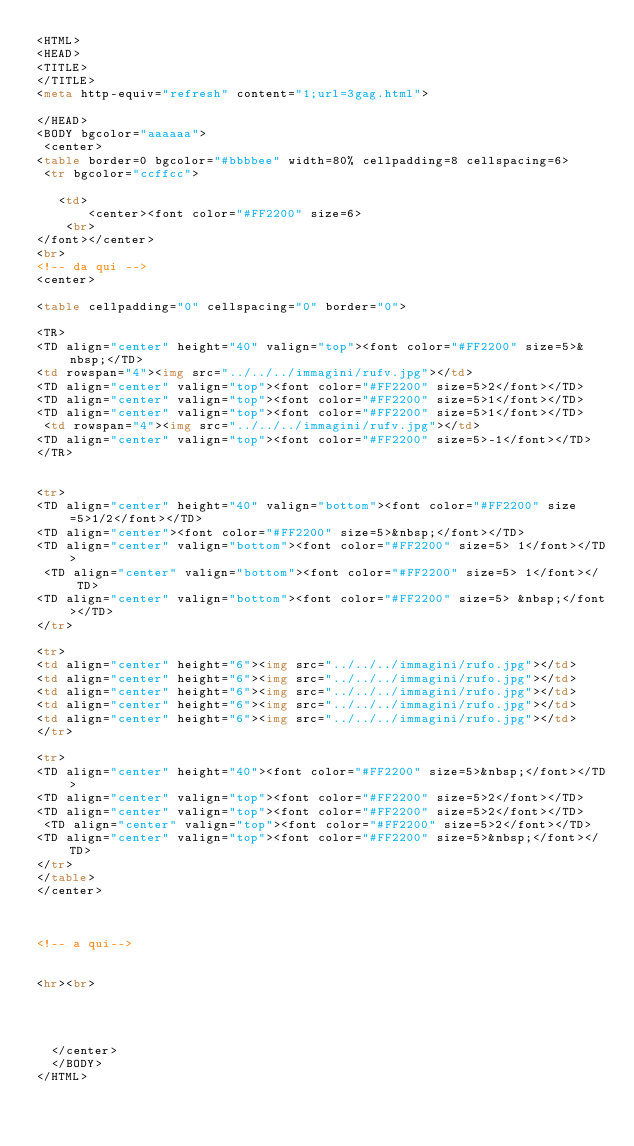Convert code to text. <code><loc_0><loc_0><loc_500><loc_500><_HTML_><HTML>
<HEAD>
<TITLE>  
</TITLE>
<meta http-equiv="refresh" content="1;url=3gag.html">

</HEAD>
<BODY bgcolor="aaaaaa">
 <center>
<table border=0 bgcolor="#bbbbee" width=80% cellpadding=8 cellspacing=6>
 <tr bgcolor="ccffcc">

   <td>
       <center><font color="#FF2200" size=6>
    <br>   
</font></center>
<br>
<!-- da qui -->
<center>

<table cellpadding="0" cellspacing="0" border="0">

<TR>
<TD align="center" height="40" valign="top"><font color="#FF2200" size=5>&nbsp;</TD>
<td rowspan="4"><img src="../../../immagini/rufv.jpg"></td>
<TD align="center" valign="top"><font color="#FF2200" size=5>2</font></TD>
<TD align="center" valign="top"><font color="#FF2200" size=5>1</font></TD>
<TD align="center" valign="top"><font color="#FF2200" size=5>1</font></TD>
 <td rowspan="4"><img src="../../../immagini/rufv.jpg"></td>
<TD align="center" valign="top"><font color="#FF2200" size=5>-1</font></TD>
</TR>

 
<tr>
<TD align="center" height="40" valign="bottom"><font color="#FF2200" size=5>1/2</font></TD>
<TD align="center"><font color="#FF2200" size=5>&nbsp;</font></TD>
<TD align="center" valign="bottom"><font color="#FF2200" size=5> 1</font></TD>
 <TD align="center" valign="bottom"><font color="#FF2200" size=5> 1</font></TD>
<TD align="center" valign="bottom"><font color="#FF2200" size=5> &nbsp;</font></TD>
</tr>

<tr>
<td align="center" height="6"><img src="../../../immagini/rufo.jpg"></td>
<td align="center" height="6"><img src="../../../immagini/rufo.jpg"></td>
<td align="center" height="6"><img src="../../../immagini/rufo.jpg"></td>
<td align="center" height="6"><img src="../../../immagini/rufo.jpg"></td>
<td align="center" height="6"><img src="../../../immagini/rufo.jpg"></td>
</tr>

<tr>
<TD align="center" height="40"><font color="#FF2200" size=5>&nbsp;</font></TD>
<TD align="center" valign="top"><font color="#FF2200" size=5>2</font></TD>
<TD align="center" valign="top"><font color="#FF2200" size=5>2</font></TD>
 <TD align="center" valign="top"><font color="#FF2200" size=5>2</font></TD>
<TD align="center" valign="top"><font color="#FF2200" size=5>&nbsp;</font></TD>
</tr>
</table>
</center>
  


<!-- a qui-->


<hr><br>

 
 
  
  </center>
  </BODY>
</HTML></code> 